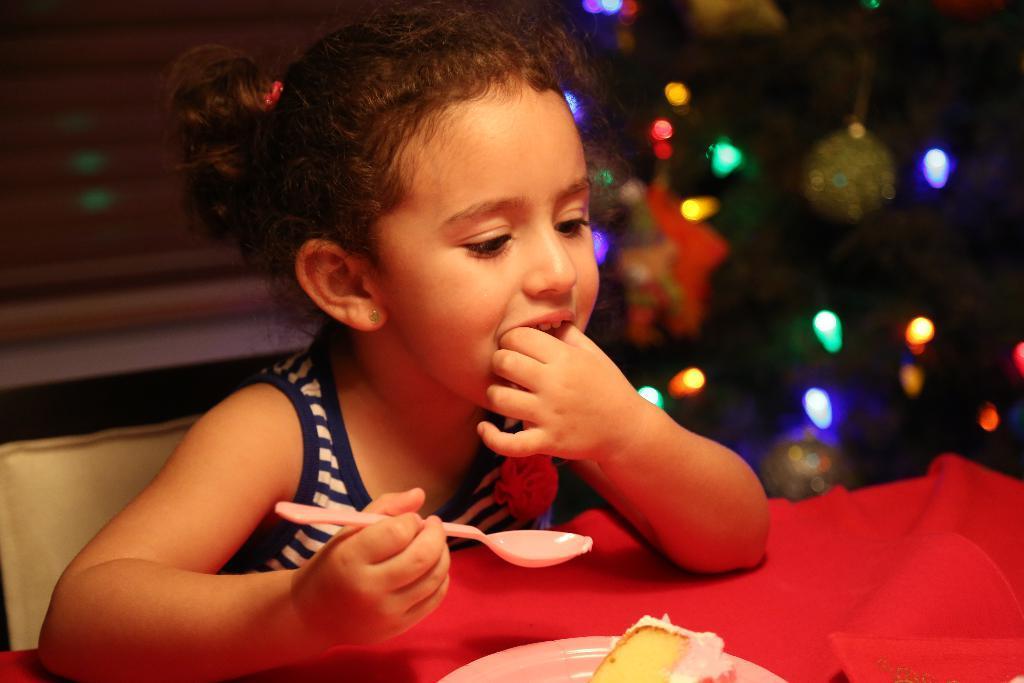In one or two sentences, can you explain what this image depicts? In this image we can see a girl holding a spoon in her hand is sitting on a chair. At the bottom of the image we can see plate containing food placed on the table. On the right side of the image we can see some lights and balls on a tree. On the left side of the image we can see window blinds. 